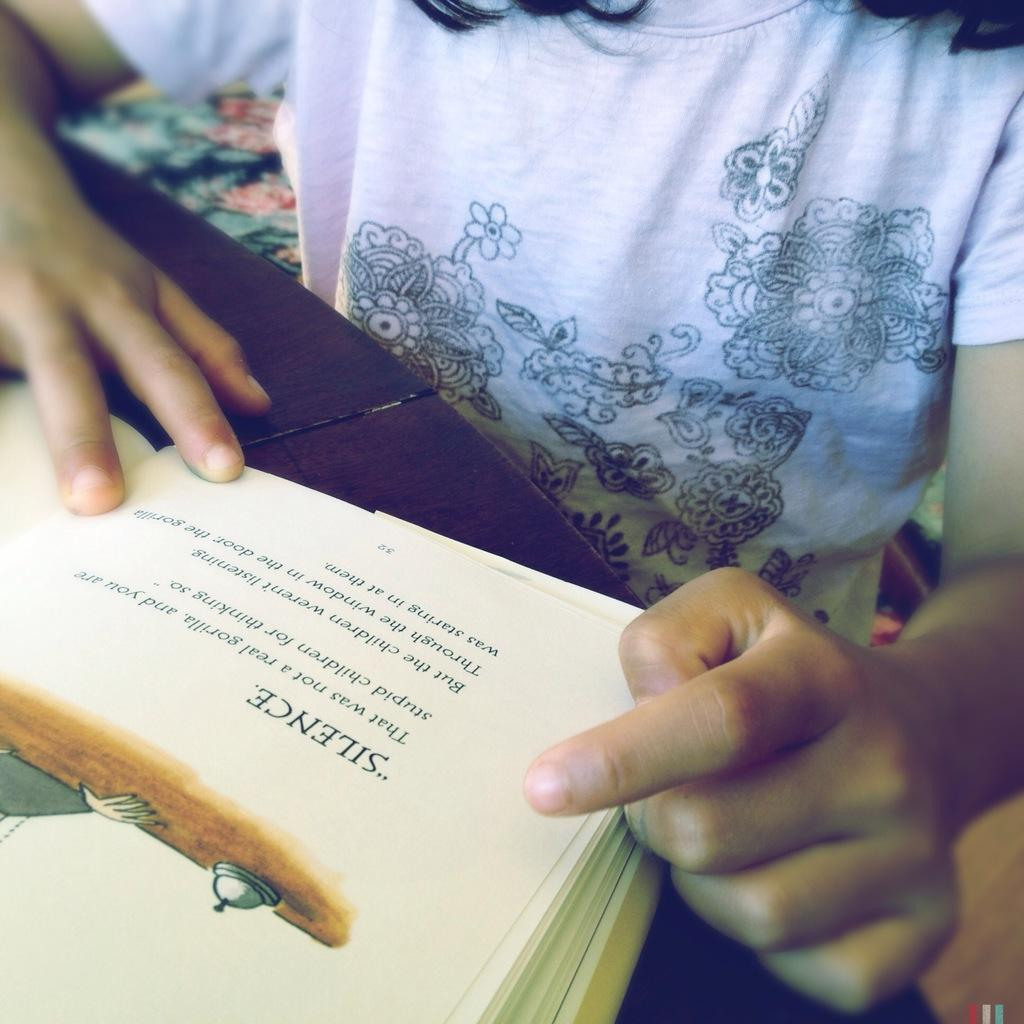<image>
Render a clear and concise summary of the photo. A child reading a book where the first line of dialogue is Silence 